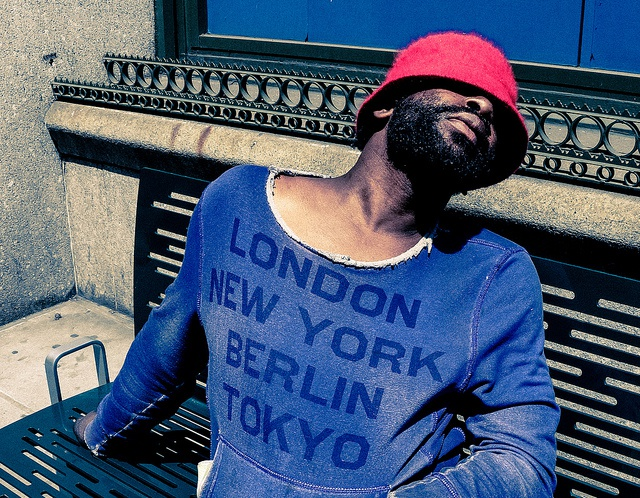Describe the objects in this image and their specific colors. I can see people in darkgray, blue, black, gray, and darkblue tones and bench in darkgray, black, darkblue, and blue tones in this image. 